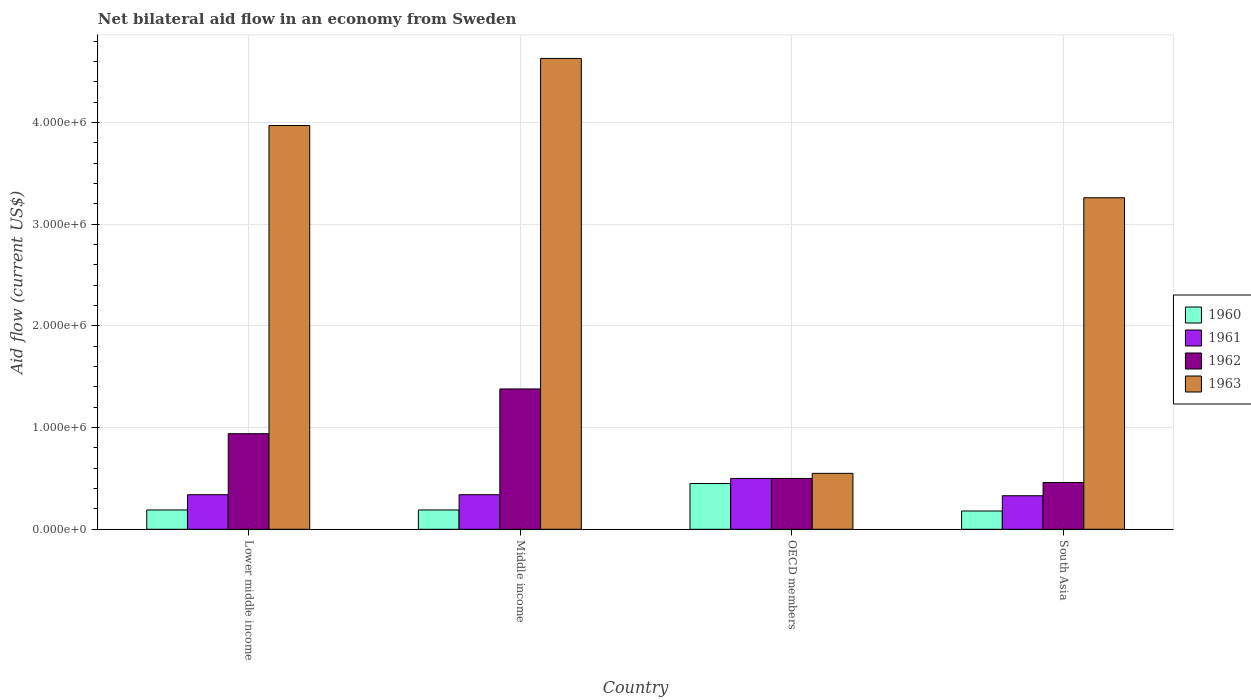What is the label of the 4th group of bars from the left?
Offer a terse response. South Asia. In how many cases, is the number of bars for a given country not equal to the number of legend labels?
Your response must be concise. 0. What is the net bilateral aid flow in 1961 in Middle income?
Your response must be concise. 3.40e+05. Across all countries, what is the maximum net bilateral aid flow in 1963?
Provide a succinct answer. 4.63e+06. What is the total net bilateral aid flow in 1961 in the graph?
Ensure brevity in your answer.  1.51e+06. What is the difference between the net bilateral aid flow in 1960 in OECD members and that in South Asia?
Provide a short and direct response. 2.70e+05. What is the difference between the net bilateral aid flow in 1961 in South Asia and the net bilateral aid flow in 1962 in Lower middle income?
Provide a short and direct response. -6.10e+05. What is the average net bilateral aid flow in 1962 per country?
Give a very brief answer. 8.20e+05. What is the difference between the net bilateral aid flow of/in 1960 and net bilateral aid flow of/in 1961 in Lower middle income?
Ensure brevity in your answer.  -1.50e+05. In how many countries, is the net bilateral aid flow in 1961 greater than 1000000 US$?
Make the answer very short. 0. What is the ratio of the net bilateral aid flow in 1963 in Middle income to that in OECD members?
Provide a succinct answer. 8.42. What is the difference between the highest and the second highest net bilateral aid flow in 1962?
Make the answer very short. 8.80e+05. What is the difference between the highest and the lowest net bilateral aid flow in 1961?
Offer a terse response. 1.70e+05. Is it the case that in every country, the sum of the net bilateral aid flow in 1960 and net bilateral aid flow in 1963 is greater than the sum of net bilateral aid flow in 1962 and net bilateral aid flow in 1961?
Your answer should be very brief. Yes. What does the 2nd bar from the left in Middle income represents?
Your answer should be very brief. 1961. Is it the case that in every country, the sum of the net bilateral aid flow in 1960 and net bilateral aid flow in 1963 is greater than the net bilateral aid flow in 1961?
Your answer should be very brief. Yes. Are all the bars in the graph horizontal?
Your response must be concise. No. What is the difference between two consecutive major ticks on the Y-axis?
Your response must be concise. 1.00e+06. Where does the legend appear in the graph?
Give a very brief answer. Center right. How many legend labels are there?
Make the answer very short. 4. What is the title of the graph?
Provide a succinct answer. Net bilateral aid flow in an economy from Sweden. Does "2000" appear as one of the legend labels in the graph?
Your answer should be compact. No. What is the Aid flow (current US$) of 1960 in Lower middle income?
Ensure brevity in your answer.  1.90e+05. What is the Aid flow (current US$) of 1961 in Lower middle income?
Your response must be concise. 3.40e+05. What is the Aid flow (current US$) of 1962 in Lower middle income?
Your answer should be compact. 9.40e+05. What is the Aid flow (current US$) of 1963 in Lower middle income?
Your answer should be very brief. 3.97e+06. What is the Aid flow (current US$) of 1960 in Middle income?
Offer a very short reply. 1.90e+05. What is the Aid flow (current US$) of 1962 in Middle income?
Keep it short and to the point. 1.38e+06. What is the Aid flow (current US$) of 1963 in Middle income?
Make the answer very short. 4.63e+06. What is the Aid flow (current US$) of 1960 in OECD members?
Provide a short and direct response. 4.50e+05. What is the Aid flow (current US$) in 1961 in OECD members?
Ensure brevity in your answer.  5.00e+05. What is the Aid flow (current US$) of 1963 in OECD members?
Your answer should be compact. 5.50e+05. What is the Aid flow (current US$) in 1960 in South Asia?
Your answer should be very brief. 1.80e+05. What is the Aid flow (current US$) in 1962 in South Asia?
Your response must be concise. 4.60e+05. What is the Aid flow (current US$) in 1963 in South Asia?
Provide a succinct answer. 3.26e+06. Across all countries, what is the maximum Aid flow (current US$) of 1960?
Your response must be concise. 4.50e+05. Across all countries, what is the maximum Aid flow (current US$) of 1961?
Your response must be concise. 5.00e+05. Across all countries, what is the maximum Aid flow (current US$) in 1962?
Your response must be concise. 1.38e+06. Across all countries, what is the maximum Aid flow (current US$) in 1963?
Provide a succinct answer. 4.63e+06. Across all countries, what is the minimum Aid flow (current US$) of 1960?
Give a very brief answer. 1.80e+05. Across all countries, what is the minimum Aid flow (current US$) in 1961?
Give a very brief answer. 3.30e+05. Across all countries, what is the minimum Aid flow (current US$) of 1962?
Provide a short and direct response. 4.60e+05. Across all countries, what is the minimum Aid flow (current US$) of 1963?
Provide a succinct answer. 5.50e+05. What is the total Aid flow (current US$) of 1960 in the graph?
Offer a very short reply. 1.01e+06. What is the total Aid flow (current US$) in 1961 in the graph?
Provide a succinct answer. 1.51e+06. What is the total Aid flow (current US$) of 1962 in the graph?
Make the answer very short. 3.28e+06. What is the total Aid flow (current US$) in 1963 in the graph?
Keep it short and to the point. 1.24e+07. What is the difference between the Aid flow (current US$) in 1960 in Lower middle income and that in Middle income?
Offer a very short reply. 0. What is the difference between the Aid flow (current US$) of 1961 in Lower middle income and that in Middle income?
Your answer should be compact. 0. What is the difference between the Aid flow (current US$) in 1962 in Lower middle income and that in Middle income?
Your response must be concise. -4.40e+05. What is the difference between the Aid flow (current US$) in 1963 in Lower middle income and that in Middle income?
Ensure brevity in your answer.  -6.60e+05. What is the difference between the Aid flow (current US$) in 1962 in Lower middle income and that in OECD members?
Provide a succinct answer. 4.40e+05. What is the difference between the Aid flow (current US$) of 1963 in Lower middle income and that in OECD members?
Your answer should be compact. 3.42e+06. What is the difference between the Aid flow (current US$) in 1961 in Lower middle income and that in South Asia?
Make the answer very short. 10000. What is the difference between the Aid flow (current US$) in 1963 in Lower middle income and that in South Asia?
Provide a succinct answer. 7.10e+05. What is the difference between the Aid flow (current US$) in 1960 in Middle income and that in OECD members?
Offer a very short reply. -2.60e+05. What is the difference between the Aid flow (current US$) in 1961 in Middle income and that in OECD members?
Provide a short and direct response. -1.60e+05. What is the difference between the Aid flow (current US$) of 1962 in Middle income and that in OECD members?
Give a very brief answer. 8.80e+05. What is the difference between the Aid flow (current US$) in 1963 in Middle income and that in OECD members?
Your answer should be very brief. 4.08e+06. What is the difference between the Aid flow (current US$) of 1960 in Middle income and that in South Asia?
Give a very brief answer. 10000. What is the difference between the Aid flow (current US$) in 1961 in Middle income and that in South Asia?
Your answer should be very brief. 10000. What is the difference between the Aid flow (current US$) of 1962 in Middle income and that in South Asia?
Your answer should be very brief. 9.20e+05. What is the difference between the Aid flow (current US$) in 1963 in Middle income and that in South Asia?
Provide a succinct answer. 1.37e+06. What is the difference between the Aid flow (current US$) of 1963 in OECD members and that in South Asia?
Your answer should be very brief. -2.71e+06. What is the difference between the Aid flow (current US$) in 1960 in Lower middle income and the Aid flow (current US$) in 1961 in Middle income?
Offer a terse response. -1.50e+05. What is the difference between the Aid flow (current US$) in 1960 in Lower middle income and the Aid flow (current US$) in 1962 in Middle income?
Give a very brief answer. -1.19e+06. What is the difference between the Aid flow (current US$) in 1960 in Lower middle income and the Aid flow (current US$) in 1963 in Middle income?
Give a very brief answer. -4.44e+06. What is the difference between the Aid flow (current US$) of 1961 in Lower middle income and the Aid flow (current US$) of 1962 in Middle income?
Provide a succinct answer. -1.04e+06. What is the difference between the Aid flow (current US$) in 1961 in Lower middle income and the Aid flow (current US$) in 1963 in Middle income?
Ensure brevity in your answer.  -4.29e+06. What is the difference between the Aid flow (current US$) of 1962 in Lower middle income and the Aid flow (current US$) of 1963 in Middle income?
Keep it short and to the point. -3.69e+06. What is the difference between the Aid flow (current US$) of 1960 in Lower middle income and the Aid flow (current US$) of 1961 in OECD members?
Offer a very short reply. -3.10e+05. What is the difference between the Aid flow (current US$) of 1960 in Lower middle income and the Aid flow (current US$) of 1962 in OECD members?
Provide a succinct answer. -3.10e+05. What is the difference between the Aid flow (current US$) in 1960 in Lower middle income and the Aid flow (current US$) in 1963 in OECD members?
Your answer should be compact. -3.60e+05. What is the difference between the Aid flow (current US$) of 1961 in Lower middle income and the Aid flow (current US$) of 1962 in OECD members?
Make the answer very short. -1.60e+05. What is the difference between the Aid flow (current US$) in 1961 in Lower middle income and the Aid flow (current US$) in 1963 in OECD members?
Provide a succinct answer. -2.10e+05. What is the difference between the Aid flow (current US$) in 1962 in Lower middle income and the Aid flow (current US$) in 1963 in OECD members?
Your answer should be compact. 3.90e+05. What is the difference between the Aid flow (current US$) of 1960 in Lower middle income and the Aid flow (current US$) of 1962 in South Asia?
Your response must be concise. -2.70e+05. What is the difference between the Aid flow (current US$) of 1960 in Lower middle income and the Aid flow (current US$) of 1963 in South Asia?
Ensure brevity in your answer.  -3.07e+06. What is the difference between the Aid flow (current US$) in 1961 in Lower middle income and the Aid flow (current US$) in 1962 in South Asia?
Keep it short and to the point. -1.20e+05. What is the difference between the Aid flow (current US$) in 1961 in Lower middle income and the Aid flow (current US$) in 1963 in South Asia?
Keep it short and to the point. -2.92e+06. What is the difference between the Aid flow (current US$) in 1962 in Lower middle income and the Aid flow (current US$) in 1963 in South Asia?
Provide a short and direct response. -2.32e+06. What is the difference between the Aid flow (current US$) in 1960 in Middle income and the Aid flow (current US$) in 1961 in OECD members?
Your answer should be compact. -3.10e+05. What is the difference between the Aid flow (current US$) in 1960 in Middle income and the Aid flow (current US$) in 1962 in OECD members?
Provide a short and direct response. -3.10e+05. What is the difference between the Aid flow (current US$) in 1960 in Middle income and the Aid flow (current US$) in 1963 in OECD members?
Your answer should be compact. -3.60e+05. What is the difference between the Aid flow (current US$) in 1961 in Middle income and the Aid flow (current US$) in 1962 in OECD members?
Give a very brief answer. -1.60e+05. What is the difference between the Aid flow (current US$) in 1962 in Middle income and the Aid flow (current US$) in 1963 in OECD members?
Make the answer very short. 8.30e+05. What is the difference between the Aid flow (current US$) of 1960 in Middle income and the Aid flow (current US$) of 1962 in South Asia?
Your answer should be compact. -2.70e+05. What is the difference between the Aid flow (current US$) in 1960 in Middle income and the Aid flow (current US$) in 1963 in South Asia?
Provide a succinct answer. -3.07e+06. What is the difference between the Aid flow (current US$) in 1961 in Middle income and the Aid flow (current US$) in 1963 in South Asia?
Your answer should be compact. -2.92e+06. What is the difference between the Aid flow (current US$) of 1962 in Middle income and the Aid flow (current US$) of 1963 in South Asia?
Offer a terse response. -1.88e+06. What is the difference between the Aid flow (current US$) in 1960 in OECD members and the Aid flow (current US$) in 1961 in South Asia?
Make the answer very short. 1.20e+05. What is the difference between the Aid flow (current US$) in 1960 in OECD members and the Aid flow (current US$) in 1962 in South Asia?
Your answer should be compact. -10000. What is the difference between the Aid flow (current US$) of 1960 in OECD members and the Aid flow (current US$) of 1963 in South Asia?
Your answer should be compact. -2.81e+06. What is the difference between the Aid flow (current US$) in 1961 in OECD members and the Aid flow (current US$) in 1962 in South Asia?
Provide a succinct answer. 4.00e+04. What is the difference between the Aid flow (current US$) in 1961 in OECD members and the Aid flow (current US$) in 1963 in South Asia?
Keep it short and to the point. -2.76e+06. What is the difference between the Aid flow (current US$) of 1962 in OECD members and the Aid flow (current US$) of 1963 in South Asia?
Give a very brief answer. -2.76e+06. What is the average Aid flow (current US$) of 1960 per country?
Offer a terse response. 2.52e+05. What is the average Aid flow (current US$) of 1961 per country?
Ensure brevity in your answer.  3.78e+05. What is the average Aid flow (current US$) of 1962 per country?
Ensure brevity in your answer.  8.20e+05. What is the average Aid flow (current US$) in 1963 per country?
Provide a short and direct response. 3.10e+06. What is the difference between the Aid flow (current US$) of 1960 and Aid flow (current US$) of 1962 in Lower middle income?
Offer a very short reply. -7.50e+05. What is the difference between the Aid flow (current US$) in 1960 and Aid flow (current US$) in 1963 in Lower middle income?
Make the answer very short. -3.78e+06. What is the difference between the Aid flow (current US$) of 1961 and Aid flow (current US$) of 1962 in Lower middle income?
Your answer should be compact. -6.00e+05. What is the difference between the Aid flow (current US$) of 1961 and Aid flow (current US$) of 1963 in Lower middle income?
Provide a succinct answer. -3.63e+06. What is the difference between the Aid flow (current US$) in 1962 and Aid flow (current US$) in 1963 in Lower middle income?
Provide a short and direct response. -3.03e+06. What is the difference between the Aid flow (current US$) in 1960 and Aid flow (current US$) in 1962 in Middle income?
Offer a terse response. -1.19e+06. What is the difference between the Aid flow (current US$) in 1960 and Aid flow (current US$) in 1963 in Middle income?
Provide a succinct answer. -4.44e+06. What is the difference between the Aid flow (current US$) of 1961 and Aid flow (current US$) of 1962 in Middle income?
Ensure brevity in your answer.  -1.04e+06. What is the difference between the Aid flow (current US$) of 1961 and Aid flow (current US$) of 1963 in Middle income?
Provide a short and direct response. -4.29e+06. What is the difference between the Aid flow (current US$) in 1962 and Aid flow (current US$) in 1963 in Middle income?
Your answer should be compact. -3.25e+06. What is the difference between the Aid flow (current US$) in 1961 and Aid flow (current US$) in 1963 in OECD members?
Ensure brevity in your answer.  -5.00e+04. What is the difference between the Aid flow (current US$) in 1960 and Aid flow (current US$) in 1962 in South Asia?
Give a very brief answer. -2.80e+05. What is the difference between the Aid flow (current US$) of 1960 and Aid flow (current US$) of 1963 in South Asia?
Make the answer very short. -3.08e+06. What is the difference between the Aid flow (current US$) in 1961 and Aid flow (current US$) in 1962 in South Asia?
Offer a terse response. -1.30e+05. What is the difference between the Aid flow (current US$) of 1961 and Aid flow (current US$) of 1963 in South Asia?
Give a very brief answer. -2.93e+06. What is the difference between the Aid flow (current US$) of 1962 and Aid flow (current US$) of 1963 in South Asia?
Your answer should be compact. -2.80e+06. What is the ratio of the Aid flow (current US$) of 1960 in Lower middle income to that in Middle income?
Make the answer very short. 1. What is the ratio of the Aid flow (current US$) of 1962 in Lower middle income to that in Middle income?
Offer a terse response. 0.68. What is the ratio of the Aid flow (current US$) in 1963 in Lower middle income to that in Middle income?
Provide a short and direct response. 0.86. What is the ratio of the Aid flow (current US$) of 1960 in Lower middle income to that in OECD members?
Your answer should be compact. 0.42. What is the ratio of the Aid flow (current US$) of 1961 in Lower middle income to that in OECD members?
Your answer should be compact. 0.68. What is the ratio of the Aid flow (current US$) of 1962 in Lower middle income to that in OECD members?
Ensure brevity in your answer.  1.88. What is the ratio of the Aid flow (current US$) in 1963 in Lower middle income to that in OECD members?
Offer a terse response. 7.22. What is the ratio of the Aid flow (current US$) of 1960 in Lower middle income to that in South Asia?
Ensure brevity in your answer.  1.06. What is the ratio of the Aid flow (current US$) of 1961 in Lower middle income to that in South Asia?
Offer a very short reply. 1.03. What is the ratio of the Aid flow (current US$) in 1962 in Lower middle income to that in South Asia?
Ensure brevity in your answer.  2.04. What is the ratio of the Aid flow (current US$) of 1963 in Lower middle income to that in South Asia?
Offer a terse response. 1.22. What is the ratio of the Aid flow (current US$) in 1960 in Middle income to that in OECD members?
Give a very brief answer. 0.42. What is the ratio of the Aid flow (current US$) in 1961 in Middle income to that in OECD members?
Keep it short and to the point. 0.68. What is the ratio of the Aid flow (current US$) in 1962 in Middle income to that in OECD members?
Provide a short and direct response. 2.76. What is the ratio of the Aid flow (current US$) of 1963 in Middle income to that in OECD members?
Your answer should be compact. 8.42. What is the ratio of the Aid flow (current US$) of 1960 in Middle income to that in South Asia?
Offer a terse response. 1.06. What is the ratio of the Aid flow (current US$) in 1961 in Middle income to that in South Asia?
Make the answer very short. 1.03. What is the ratio of the Aid flow (current US$) of 1963 in Middle income to that in South Asia?
Your answer should be very brief. 1.42. What is the ratio of the Aid flow (current US$) in 1961 in OECD members to that in South Asia?
Provide a short and direct response. 1.52. What is the ratio of the Aid flow (current US$) in 1962 in OECD members to that in South Asia?
Your response must be concise. 1.09. What is the ratio of the Aid flow (current US$) of 1963 in OECD members to that in South Asia?
Offer a terse response. 0.17. What is the difference between the highest and the second highest Aid flow (current US$) in 1963?
Your answer should be very brief. 6.60e+05. What is the difference between the highest and the lowest Aid flow (current US$) of 1960?
Your answer should be compact. 2.70e+05. What is the difference between the highest and the lowest Aid flow (current US$) in 1962?
Ensure brevity in your answer.  9.20e+05. What is the difference between the highest and the lowest Aid flow (current US$) of 1963?
Provide a short and direct response. 4.08e+06. 